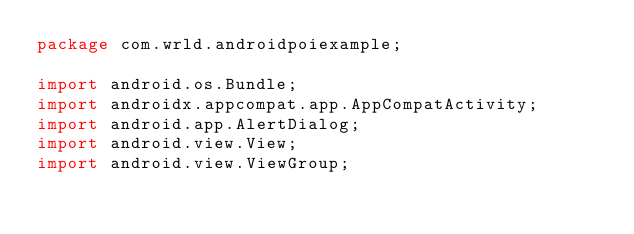Convert code to text. <code><loc_0><loc_0><loc_500><loc_500><_Java_>package com.wrld.androidpoiexample;

import android.os.Bundle;
import androidx.appcompat.app.AppCompatActivity;
import android.app.AlertDialog;
import android.view.View;
import android.view.ViewGroup;
</code> 